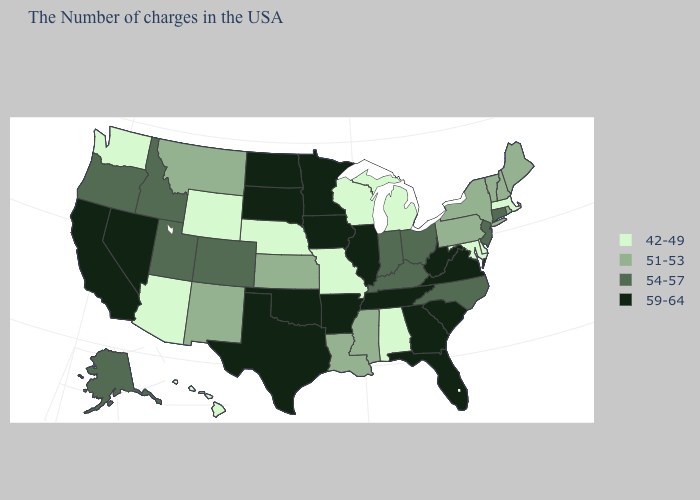What is the value of Texas?
Answer briefly. 59-64. Which states have the lowest value in the USA?
Quick response, please. Massachusetts, Delaware, Maryland, Michigan, Alabama, Wisconsin, Missouri, Nebraska, Wyoming, Arizona, Washington, Hawaii. Does Michigan have the lowest value in the USA?
Write a very short answer. Yes. What is the highest value in the USA?
Answer briefly. 59-64. Does Rhode Island have a lower value than Delaware?
Give a very brief answer. No. Which states have the highest value in the USA?
Be succinct. Virginia, South Carolina, West Virginia, Florida, Georgia, Tennessee, Illinois, Arkansas, Minnesota, Iowa, Oklahoma, Texas, South Dakota, North Dakota, Nevada, California. Name the states that have a value in the range 42-49?
Short answer required. Massachusetts, Delaware, Maryland, Michigan, Alabama, Wisconsin, Missouri, Nebraska, Wyoming, Arizona, Washington, Hawaii. What is the value of South Carolina?
Write a very short answer. 59-64. Does Washington have the lowest value in the West?
Keep it brief. Yes. What is the value of New Hampshire?
Write a very short answer. 51-53. Is the legend a continuous bar?
Write a very short answer. No. Is the legend a continuous bar?
Give a very brief answer. No. Is the legend a continuous bar?
Give a very brief answer. No. What is the lowest value in states that border New Mexico?
Be succinct. 42-49. 